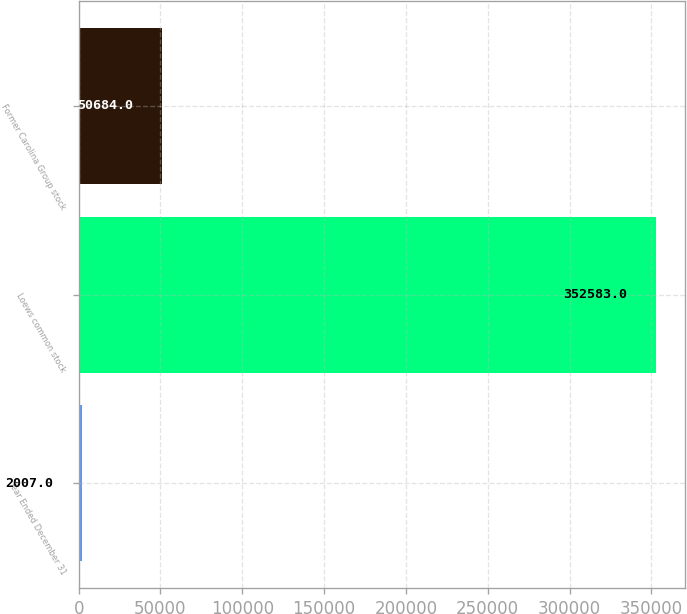Convert chart. <chart><loc_0><loc_0><loc_500><loc_500><bar_chart><fcel>Year Ended December 31<fcel>Loews common stock<fcel>Former Carolina Group stock<nl><fcel>2007<fcel>352583<fcel>50684<nl></chart> 